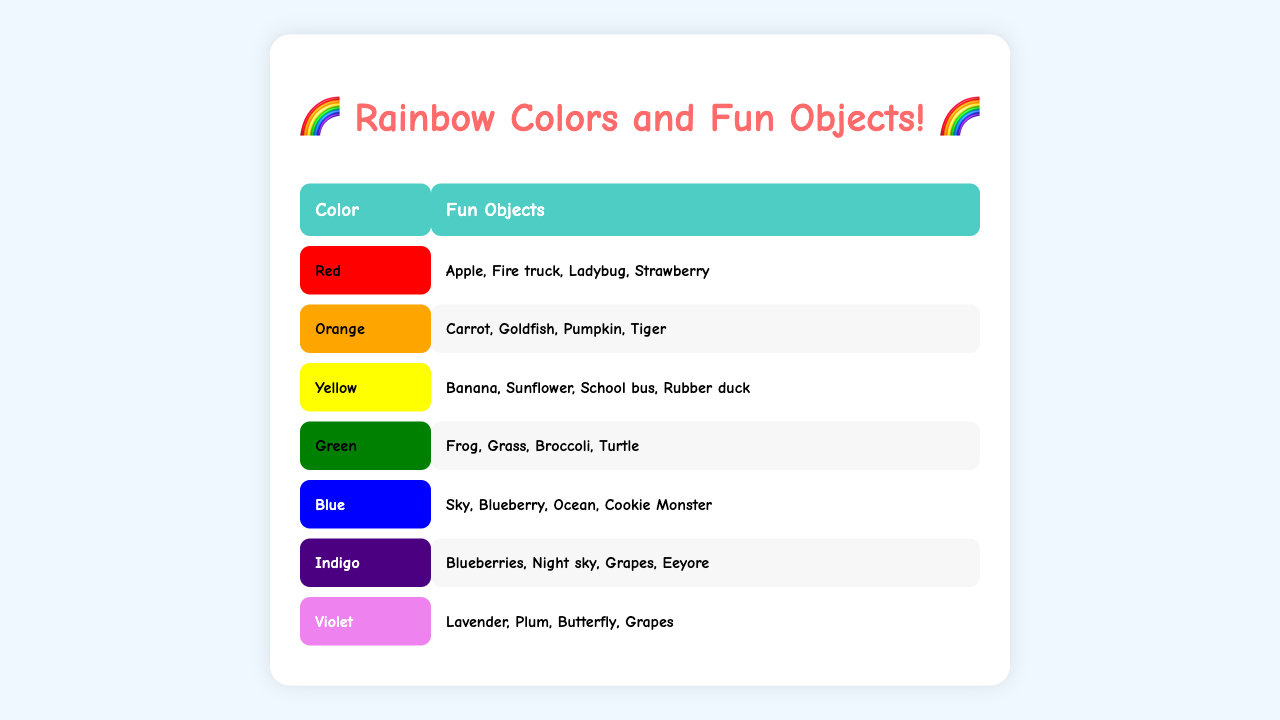What color is associated with apples? The table shows that red is the color listed for apples under the "Objects" column.
Answer: Red How many objects are listed for the color yellow? According to the table, the yellow color is associated with four objects: Banana, Sunflower, School bus, and Rubber duck.
Answer: 4 Is grass listed under the green color? Yes, the table explicitly mentions grass as one of the objects associated with the green color.
Answer: Yes Which color has the object "Grapes"? The color associated with "Grapes" appears to be indigo and violet, as grapes are listed under both of those colors in the table.
Answer: Indigo and Violet What is the difference between the number of objects for red and orange? The red color has 4 objects (Apple, Fire truck, Ladybug, Strawberry) and orange color also has 4 objects (Carrot, Goldfish, Pumpkin, Tiger), thus the difference is 0.
Answer: 0 What color has the most objects listed? Each color except for violet and indigo has 4 objects listed. Therefore, there is no single color that has more; they all have the same amount.
Answer: None How many total unique objects are listed in the table? The total number of objects is calculated by adding the objects under each color. Since some objects are repeated (like Grapes), summarize them for 21 unique objects counted from all the colors.
Answer: 21 Which objects are associated with the color blue? The table indicates that the objects linked to the blue color are Sky, Blueberry, Ocean, and Cookie Monster.
Answer: Sky, Blueberry, Ocean, Cookie Monster If you mix all colors together, which color would be represented as the last one in the list? The last color in the sequence of the table is Violet, so if combining color groupings, Violet would be the last represented.
Answer: Violet Are there any objects associated with indigo that are also listed under violet? Yes, the object "Grapes" appears in both the indigo and violet color categories as per the table.
Answer: Yes 